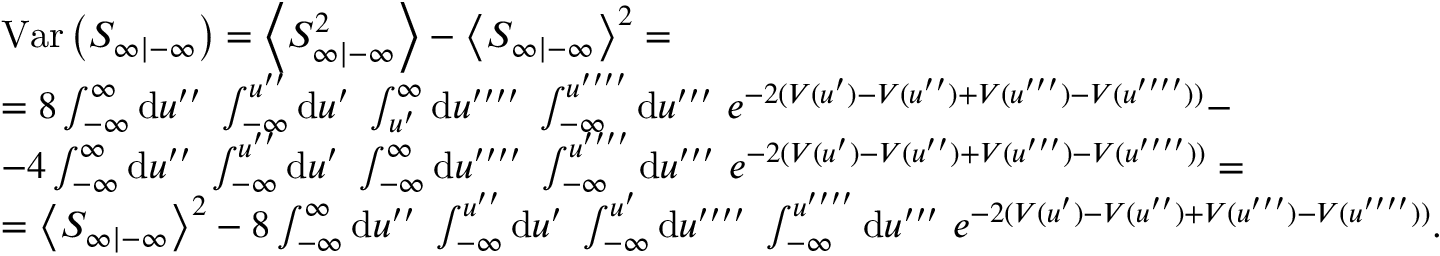<formula> <loc_0><loc_0><loc_500><loc_500>\begin{array} { r l } & { V a r \left ( S _ { \infty | - \infty } \right ) = \left \langle S _ { \infty | - \infty } ^ { 2 } \right \rangle - \left \langle S _ { \infty | - \infty } \right \rangle ^ { 2 } = } \\ & { = 8 \int _ { - \infty } ^ { \infty } d u ^ { \prime \prime } \ \int _ { - \infty } ^ { u ^ { \prime \prime } } d u ^ { \prime } \ \int _ { u ^ { \prime } } ^ { \infty } d u ^ { \prime \prime \prime \prime } \ \int _ { - \infty } ^ { u ^ { \prime \prime \prime \prime } } d u ^ { \prime \prime \prime } \ e ^ { - 2 ( V ( u ^ { \prime } ) - V ( u ^ { \prime \prime } ) + V ( u ^ { \prime \prime \prime } ) - V ( u ^ { \prime \prime \prime \prime } ) ) } - } \\ & { - 4 \int _ { - \infty } ^ { \infty } d u ^ { \prime \prime } \ \int _ { - \infty } ^ { u ^ { \prime \prime } } d u ^ { \prime } \ \int _ { - \infty } ^ { \infty } d u ^ { \prime \prime \prime \prime } \ \int _ { - \infty } ^ { u ^ { \prime \prime \prime \prime } } d u ^ { \prime \prime \prime } \ e ^ { - 2 ( V ( u ^ { \prime } ) - V ( u ^ { \prime \prime } ) + V ( u ^ { \prime \prime \prime } ) - V ( u ^ { \prime \prime \prime \prime } ) ) } = } \\ & { = \left \langle S _ { \infty | - \infty } \right \rangle ^ { 2 } - 8 \int _ { - \infty } ^ { \infty } d u ^ { \prime \prime } \ \int _ { - \infty } ^ { u ^ { \prime \prime } } d u ^ { \prime } \ \int _ { - \infty } ^ { u ^ { \prime } } d u ^ { \prime \prime \prime \prime } \ \int _ { - \infty } ^ { u ^ { \prime \prime \prime \prime } } d u ^ { \prime \prime \prime } \ e ^ { - 2 ( V ( u ^ { \prime } ) - V ( u ^ { \prime \prime } ) + V ( u ^ { \prime \prime \prime } ) - V ( u ^ { \prime \prime \prime \prime } ) ) } . } \end{array}</formula> 